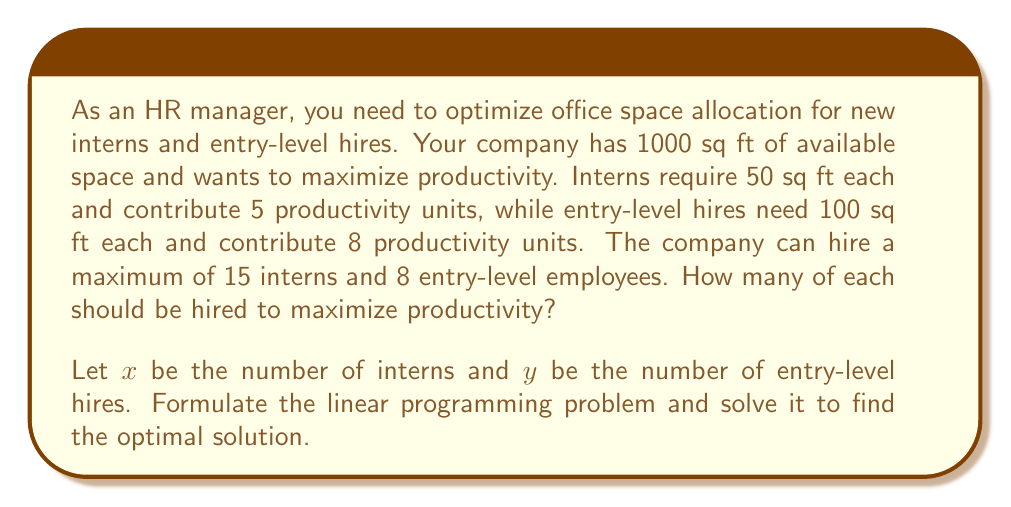Can you answer this question? 1. Formulate the linear programming problem:

   Maximize: $Z = 5x + 8y$ (productivity function)
   
   Subject to:
   $50x + 100y \leq 1000$ (space constraint)
   $x \leq 15$ (max interns)
   $y \leq 8$ (max entry-level)
   $x \geq 0, y \geq 0$ (non-negativity)

2. Graph the constraints:
   [asy]
   import geometry;
   
   size(200);
   
   real xmax = 20, ymax = 10;
   
   draw((0,0)--(xmax,0)--(xmax,ymax)--(0,ymax)--cycle);
   draw((0,10)--(20,0), blue);
   draw((15,0)--(15,ymax), red);
   draw((0,8)--(xmax,8), green);
   
   label("$50x + 100y = 1000$", (10,5), blue);
   label("$x = 15$", (15,5), red);
   label("$y = 8$", (10,8), green);
   
   dot((15,5), red);
   dot((10,8), red);
   dot((15,8), red);
   
   label("(15, 5)", (15,5), SE);
   label("(10, 8)", (10,8), NW);
   label("(15, 8)", (15,8), NE);
   [/asy]

3. Identify the feasible region and corner points:
   The feasible region is bounded by the constraints.
   Corner points: (0,0), (0,8), (10,8), (15,5), (15,0)

4. Evaluate the objective function at each corner point:
   $Z(0,0) = 0$
   $Z(0,8) = 64$
   $Z(10,8) = 114$
   $Z(15,5) = 115$
   $Z(15,0) = 75$

5. The maximum value occurs at (15,5), which corresponds to 15 interns and 5 entry-level hires.
Answer: 15 interns, 5 entry-level hires 